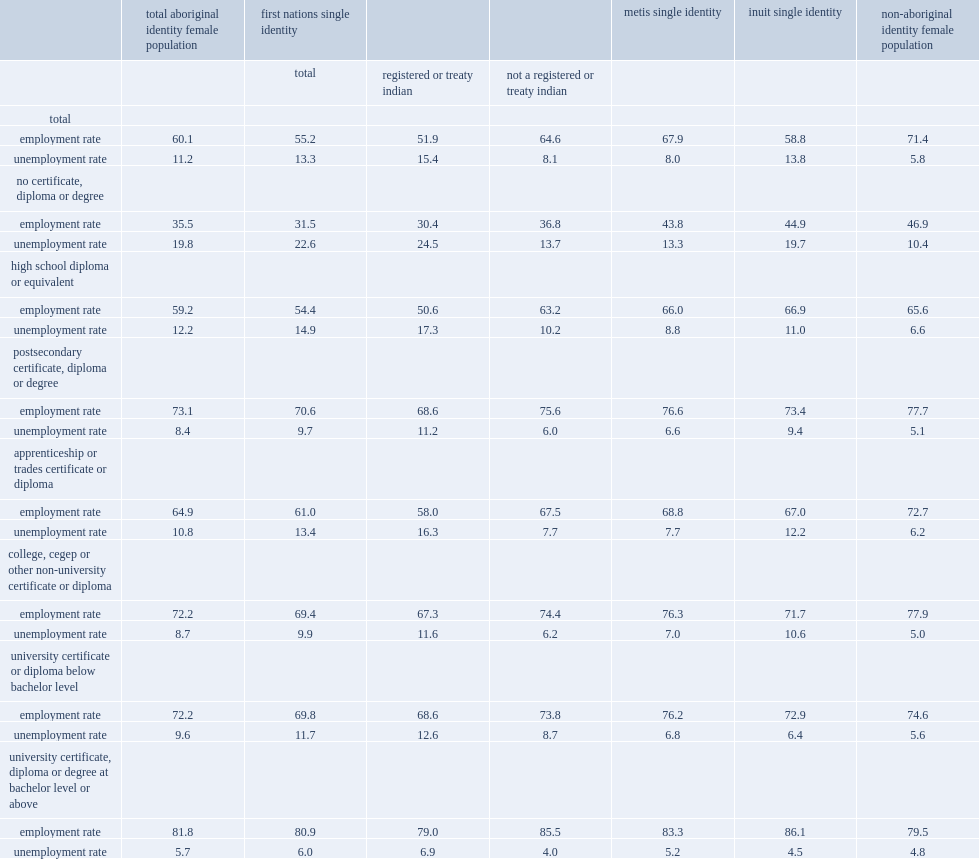How many percentages of aboriginal women aged 25 to 64 with a certificate, diploma or degree at bachelor level or above were employed? 81.8. How many percentages of non-aboriginal women aged 25 to 64 with a certificate, diploma or degree at bachelor level or above were employed? 79.5. Among aboriginal women aged 25 to 64 with no certificate, diploma or degree, how many percent were employed? 35.5. Among aboriginal women aged 25 to 64 with a high school diploma or equivalent as their highest level of education, how many percent were employed? 59.2. How many percent of aboriginal women with postsecondary credentials were employed? 73.1. How many percent of non-aboriginal women with postsecondary credentials were employed? 77.7. In 2011, among women aged 25 to 64 without a certificate, diploma or degree, what was the unemployment rate for aboriginal women? 19.8. In 2011, among women aged 25 to 64 without a certificate, diploma or degree, what was the unemployment rate for non-aboriginal women? 10.4. In 2011, among women aged 25 to 64 without a certificate, diploma or degree, the unemployment rate was 19.8% for aboriginal women and 10.4% for non-aboriginal women,what was the gap of percentage points? 9.4. In 2011, among women aged 25 to 64 without a certificate, diploma or degree, what was the unemployment rate for aboriginal women? 12.2. In 2011, among women aged 25 to 64 without a certificate, diploma or degree, what was the unemployment rate for non-aboriginal women? 6.6. In 2011, among women aged 25 to 64 without a certificate, diploma or degree, the unemployment rate was 19.8% for aboriginal women and 10.4% for non-aboriginal women,what was the gap of percentage points? 5.6. How many percentages did aboriginal women with university certificate, diploma or degree at bachelor level or above have an unemployment rate? 5.7. How many percentages did non-aboriginal women with university certificate, diploma or degree at bachelor level or above have an unemployment rate? 4.8. 